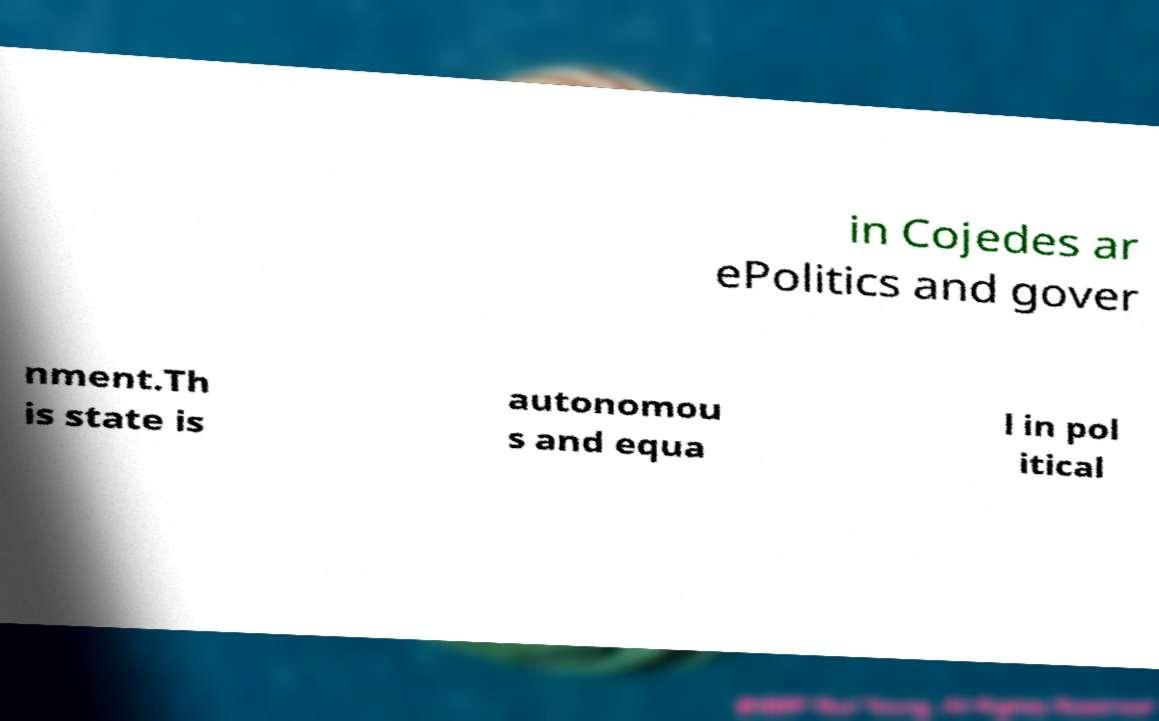Can you read and provide the text displayed in the image?This photo seems to have some interesting text. Can you extract and type it out for me? in Cojedes ar ePolitics and gover nment.Th is state is autonomou s and equa l in pol itical 